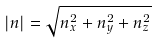Convert formula to latex. <formula><loc_0><loc_0><loc_500><loc_500>| n | = { \sqrt { n _ { x } ^ { 2 } + n _ { y } ^ { 2 } + n _ { z } ^ { 2 } } }</formula> 